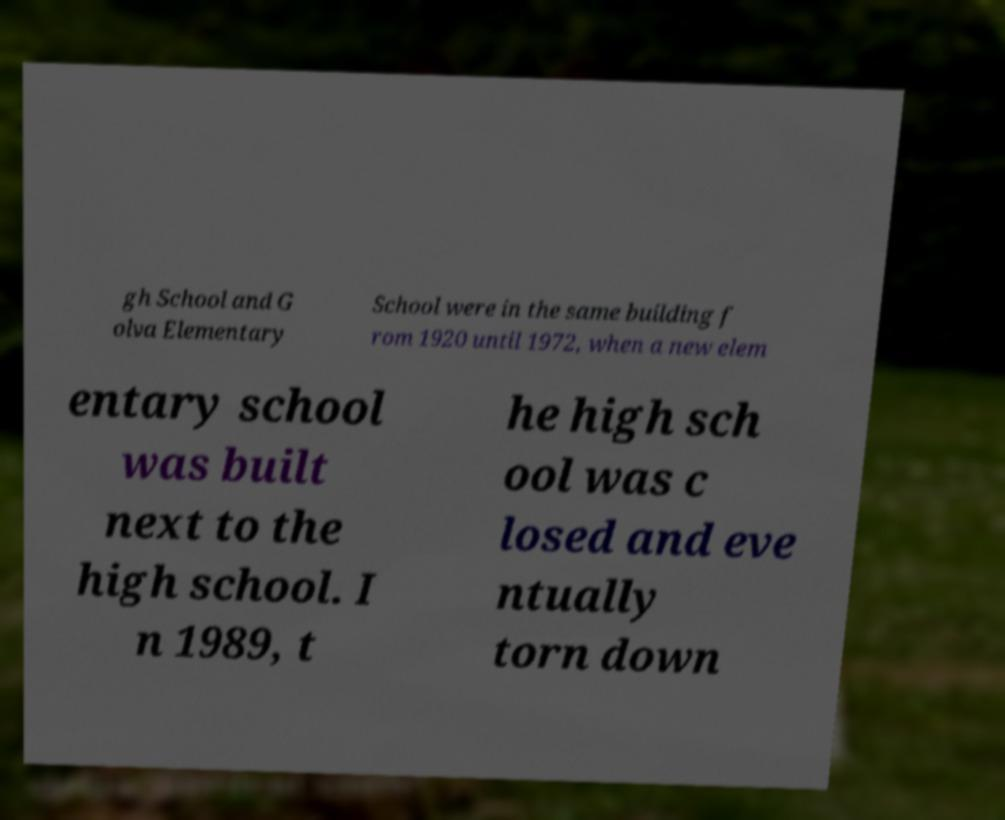There's text embedded in this image that I need extracted. Can you transcribe it verbatim? gh School and G olva Elementary School were in the same building f rom 1920 until 1972, when a new elem entary school was built next to the high school. I n 1989, t he high sch ool was c losed and eve ntually torn down 